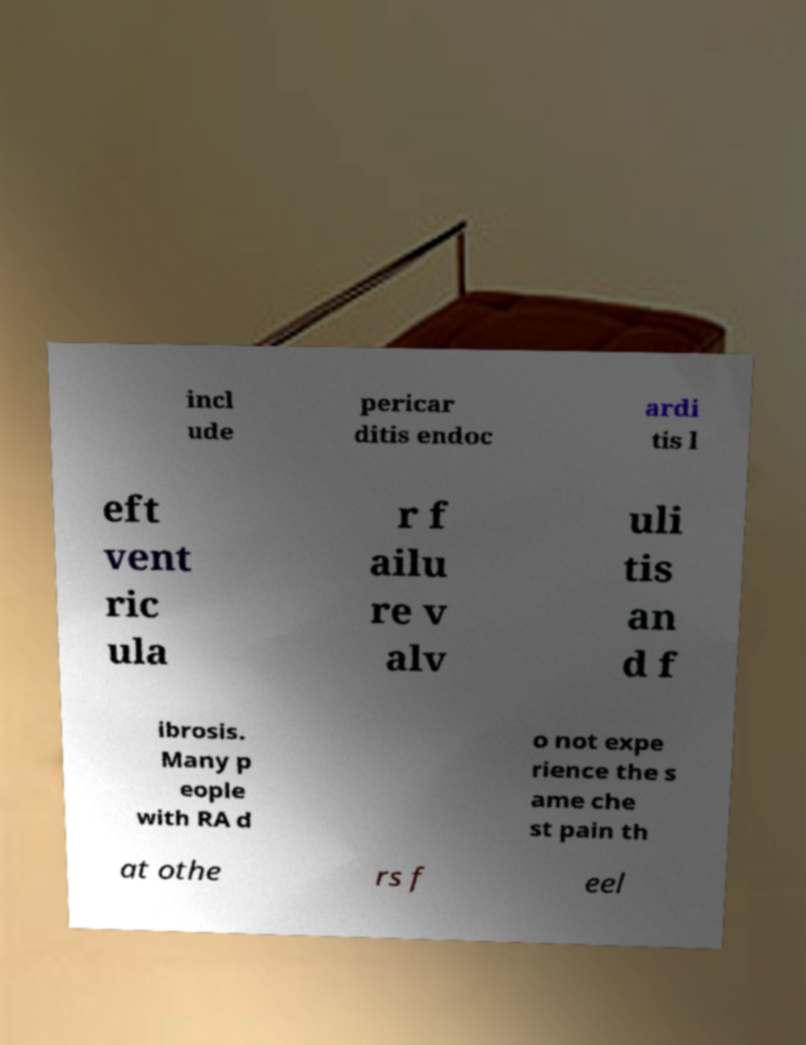Please read and relay the text visible in this image. What does it say? incl ude pericar ditis endoc ardi tis l eft vent ric ula r f ailu re v alv uli tis an d f ibrosis. Many p eople with RA d o not expe rience the s ame che st pain th at othe rs f eel 